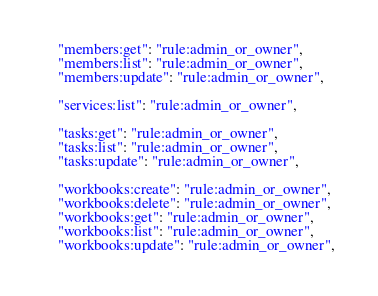Convert code to text. <code><loc_0><loc_0><loc_500><loc_500><_Python_>    "members:get": "rule:admin_or_owner",
    "members:list": "rule:admin_or_owner",
    "members:update": "rule:admin_or_owner",

    "services:list": "rule:admin_or_owner",

    "tasks:get": "rule:admin_or_owner",
    "tasks:list": "rule:admin_or_owner",
    "tasks:update": "rule:admin_or_owner",

    "workbooks:create": "rule:admin_or_owner",
    "workbooks:delete": "rule:admin_or_owner",
    "workbooks:get": "rule:admin_or_owner",
    "workbooks:list": "rule:admin_or_owner",
    "workbooks:update": "rule:admin_or_owner",
</code> 